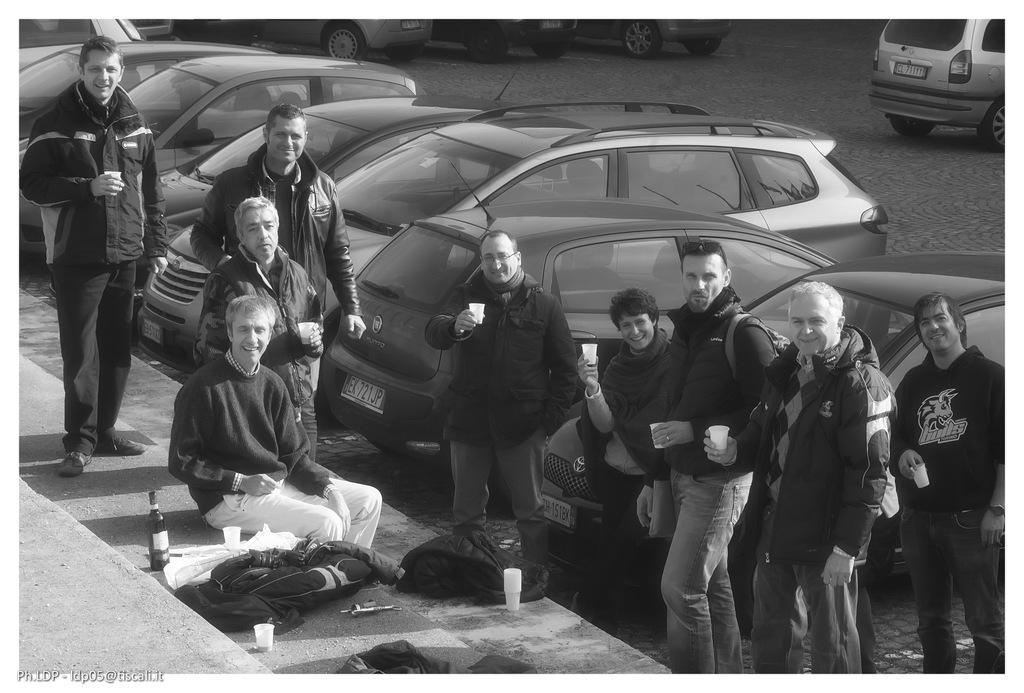Describe this image in one or two sentences. It is a black and white image there are many cars parked beside a path and a group of people are standing and posing for the photo, they are holding some cups in their hand. One of them is sitting on a step and there are some bags kept on the step. 